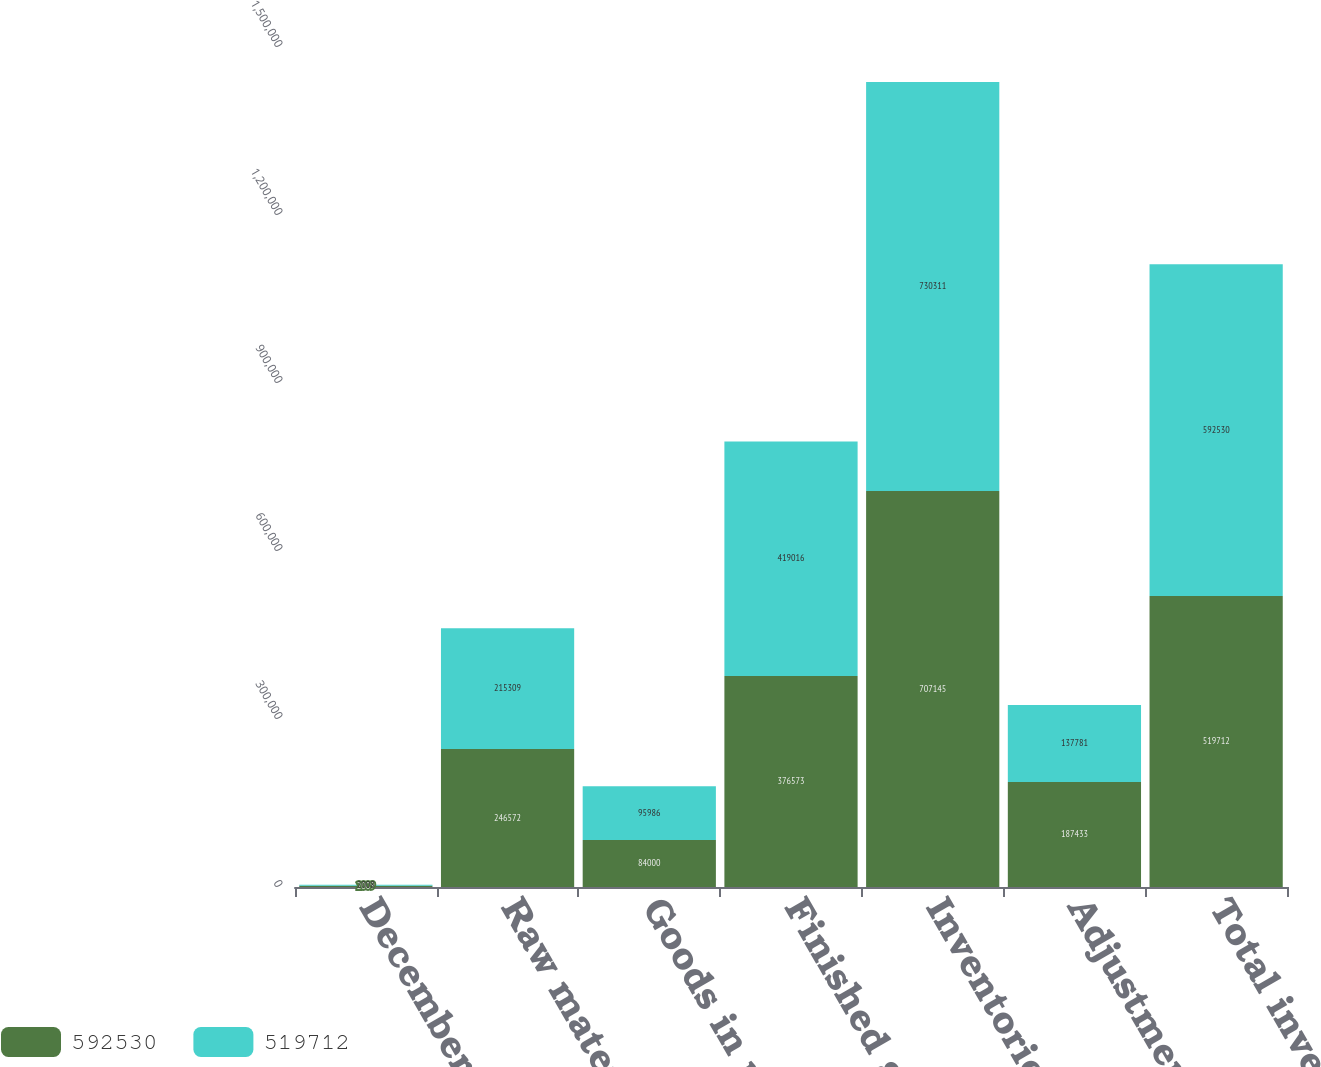Convert chart to OTSL. <chart><loc_0><loc_0><loc_500><loc_500><stacked_bar_chart><ecel><fcel>December 31<fcel>Raw materials<fcel>Goods in process<fcel>Finished goods<fcel>Inventories at FIFO<fcel>Adjustment to LIFO<fcel>Total inventories<nl><fcel>592530<fcel>2009<fcel>246572<fcel>84000<fcel>376573<fcel>707145<fcel>187433<fcel>519712<nl><fcel>519712<fcel>2008<fcel>215309<fcel>95986<fcel>419016<fcel>730311<fcel>137781<fcel>592530<nl></chart> 